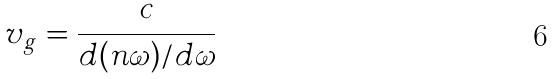<formula> <loc_0><loc_0><loc_500><loc_500>v _ { g } = \frac { c } { d ( n \omega ) / d \omega }</formula> 